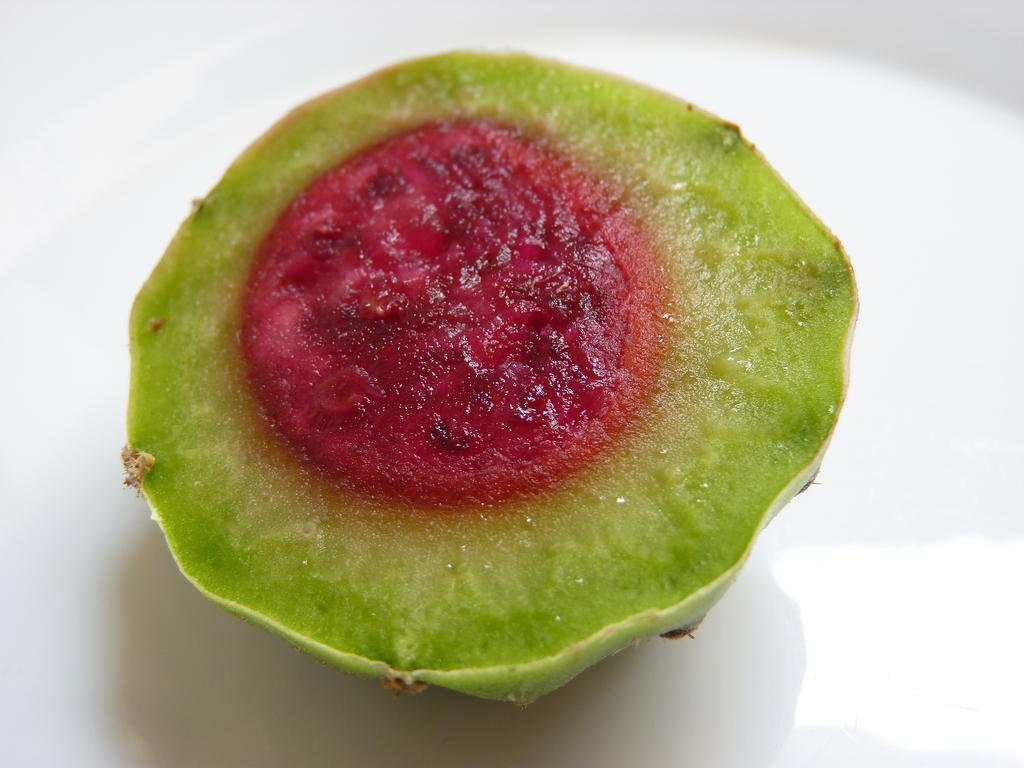What type of food is present in the image? There is a fruit in the image. What is the color of the surface on which the fruit is placed? The fruit is on a white surface. What type of soda is the writer drinking in the image? There is no writer or soda present in the image; it only features a fruit on a white surface. 